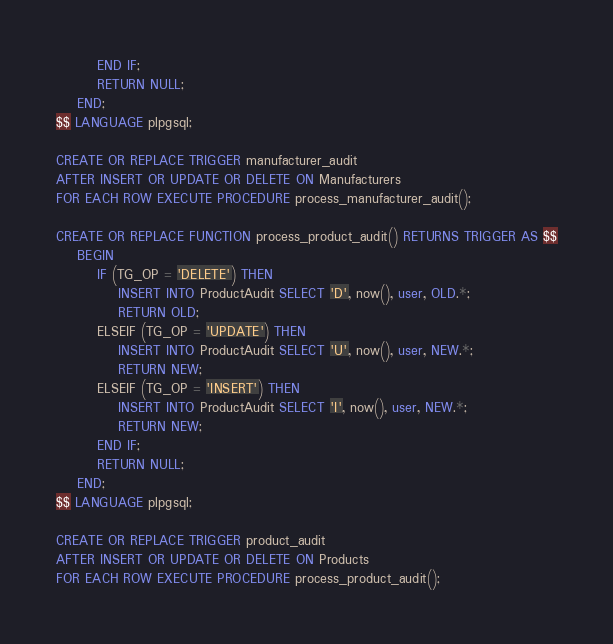<code> <loc_0><loc_0><loc_500><loc_500><_SQL_>        END IF;
        RETURN NULL;
    END;
$$ LANGUAGE plpgsql;

CREATE OR REPLACE TRIGGER manufacturer_audit
AFTER INSERT OR UPDATE OR DELETE ON Manufacturers
FOR EACH ROW EXECUTE PROCEDURE process_manufacturer_audit();

CREATE OR REPLACE FUNCTION process_product_audit() RETURNS TRIGGER AS $$
    BEGIN
        IF (TG_OP = 'DELETE') THEN
            INSERT INTO ProductAudit SELECT 'D', now(), user, OLD.*;
            RETURN OLD;
        ELSEIF (TG_OP = 'UPDATE') THEN
            INSERT INTO ProductAudit SELECT 'U', now(), user, NEW.*;
            RETURN NEW;
        ELSEIF (TG_OP = 'INSERT') THEN
            INSERT INTO ProductAudit SELECT 'I', now(), user, NEW.*;
            RETURN NEW;
        END IF;
        RETURN NULL;
    END;
$$ LANGUAGE plpgsql;

CREATE OR REPLACE TRIGGER product_audit
AFTER INSERT OR UPDATE OR DELETE ON Products
FOR EACH ROW EXECUTE PROCEDURE process_product_audit();</code> 